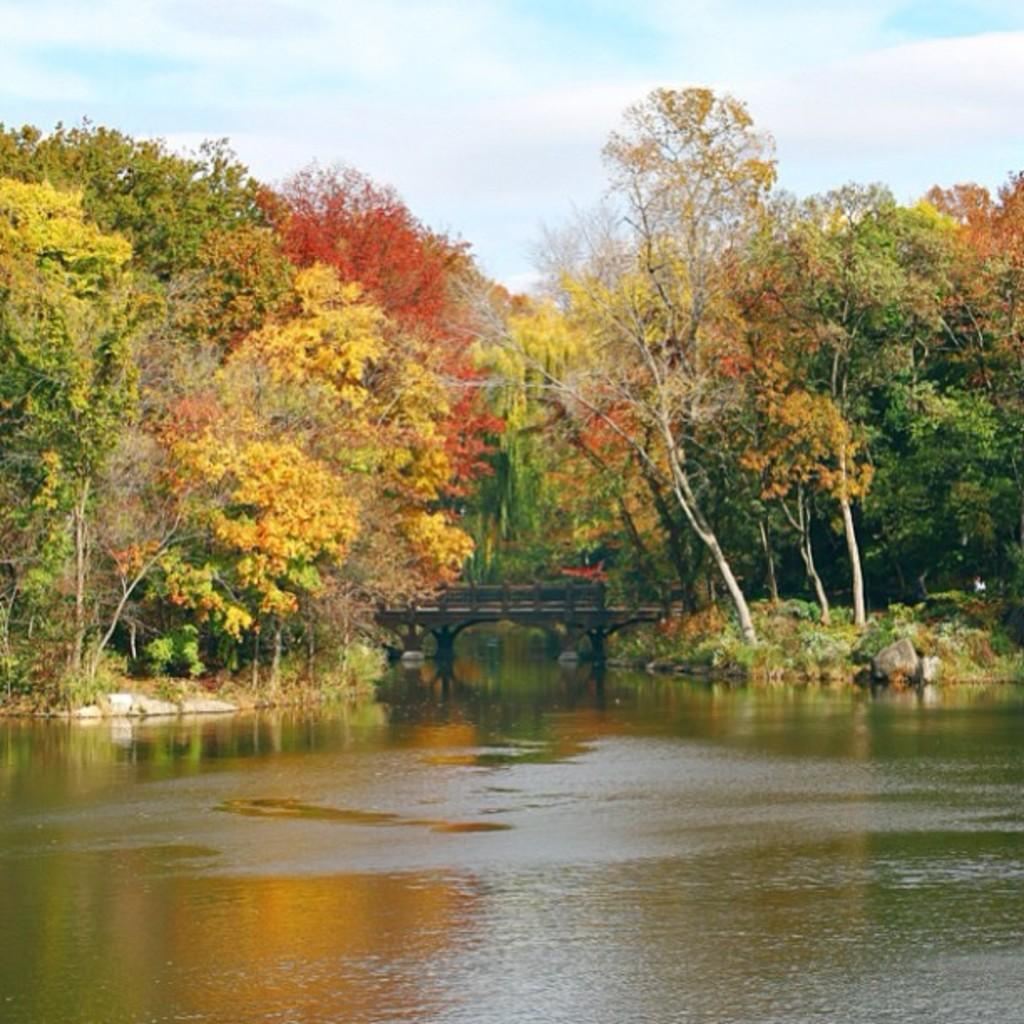What type of natural feature is present in the image? There is a river in the image. What can be seen in the background of the image? There are trees and a bridge in the background of the image. What is visible in the sky in the image? The sky is visible in the background of the image. Where is the airport located in the image? There is no airport present in the image. What type of jelly can be seen floating on the river in the image? There is no jelly present in the image; it is a river with no visible jelly. 